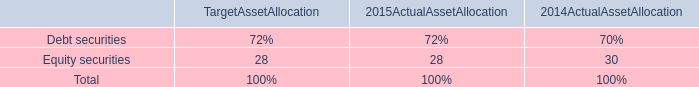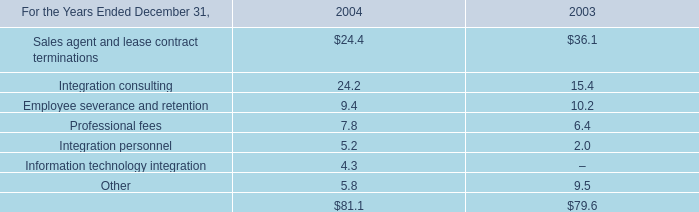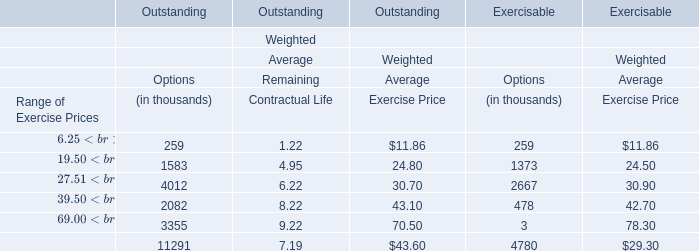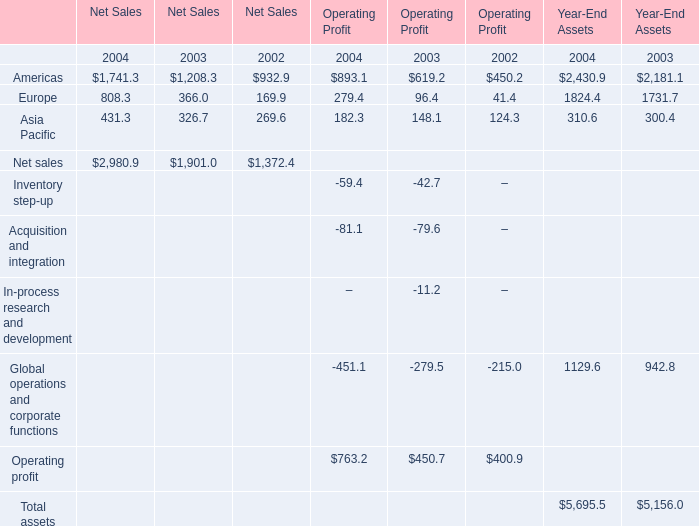What is the sum of Americas, Europe and Asia Pacific in 2003 of net sales? 
Computations: ((1208.3 + 366) + 326.7)
Answer: 1901.0. 